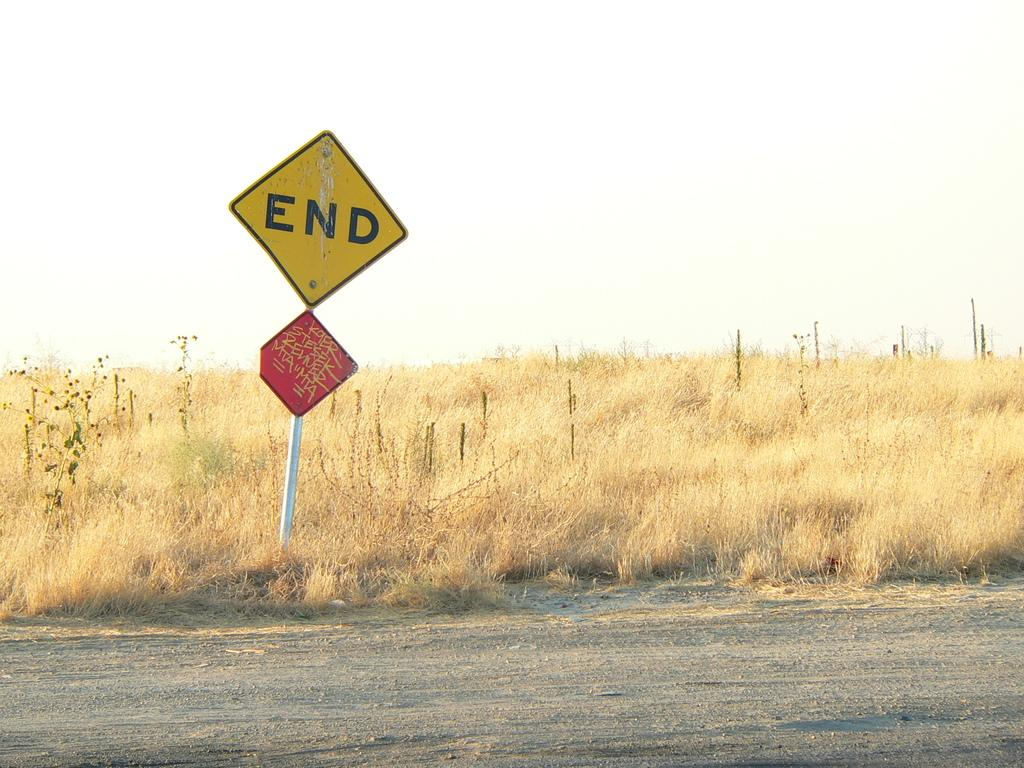Provide a one-sentence caption for the provided image. A sign saying end next to an overgrown field. 